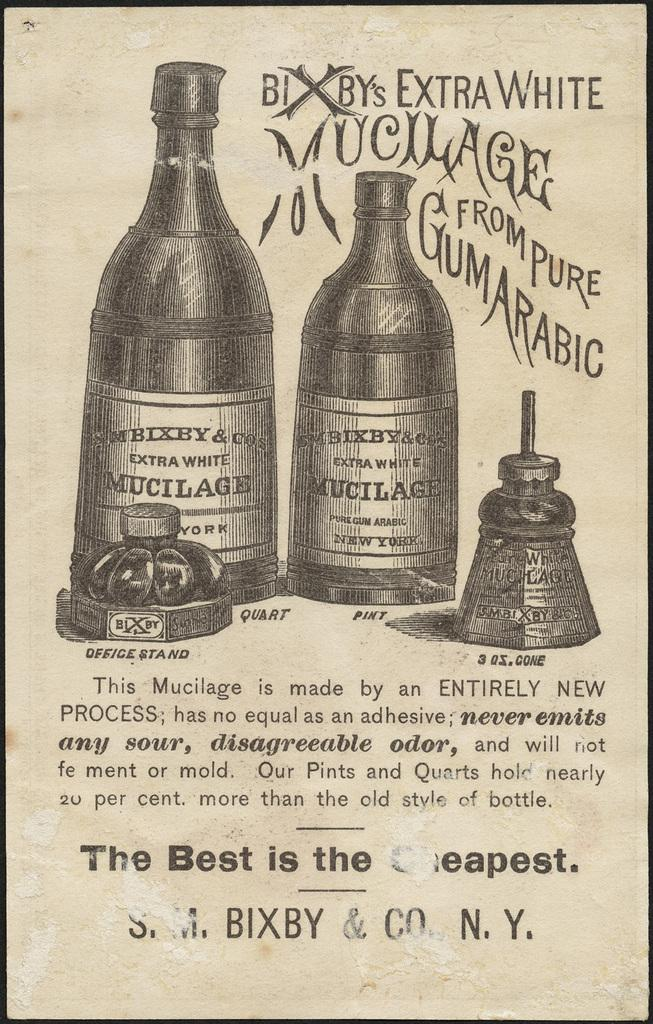<image>
Offer a succinct explanation of the picture presented. Bixby's Extra White Mucilage from Pure Gum Arabic, has a label on the bottom saying the best is the cheapest. 